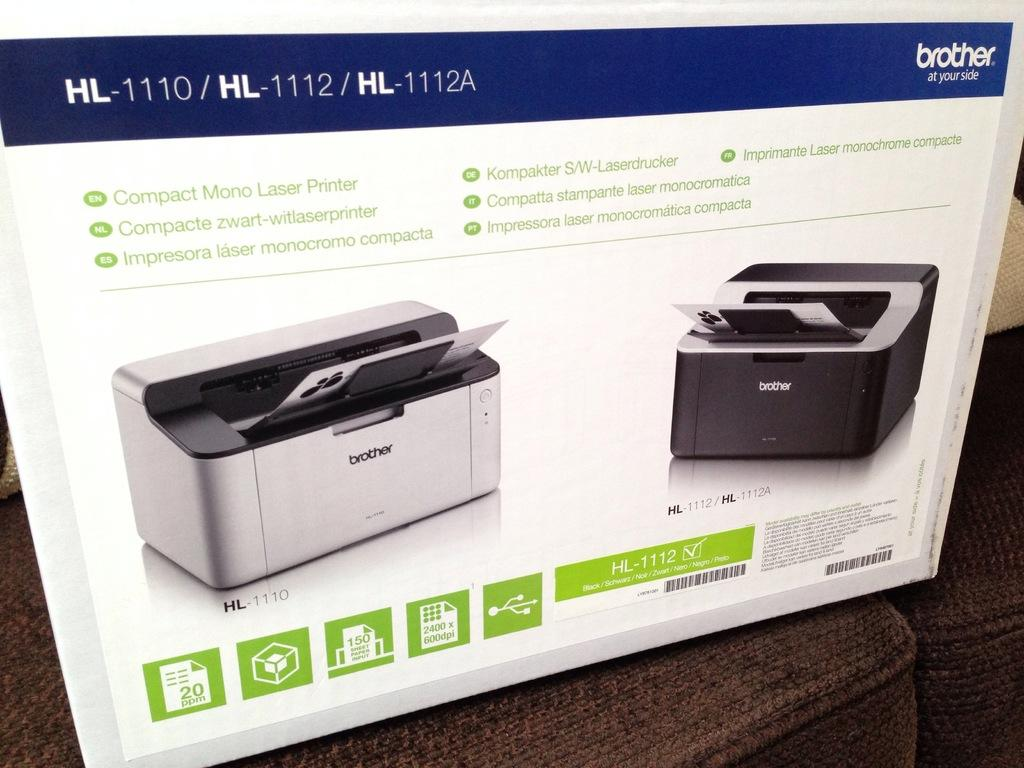Provide a one-sentence caption for the provided image. The Brother HL-1110 is a Mono Laser Printer, not a color printer. 